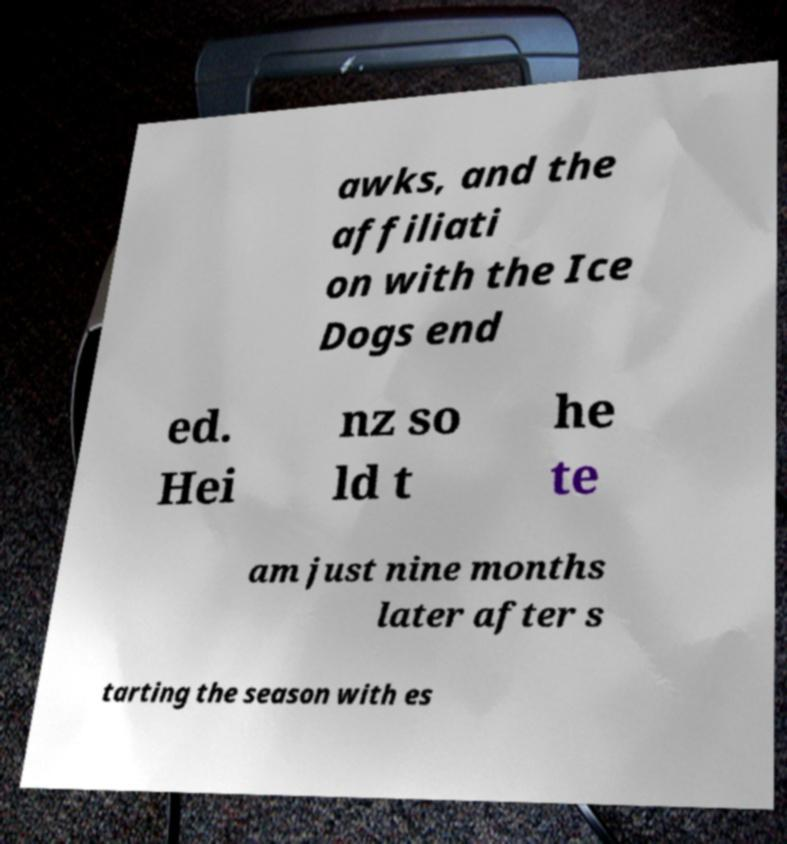Please read and relay the text visible in this image. What does it say? awks, and the affiliati on with the Ice Dogs end ed. Hei nz so ld t he te am just nine months later after s tarting the season with es 